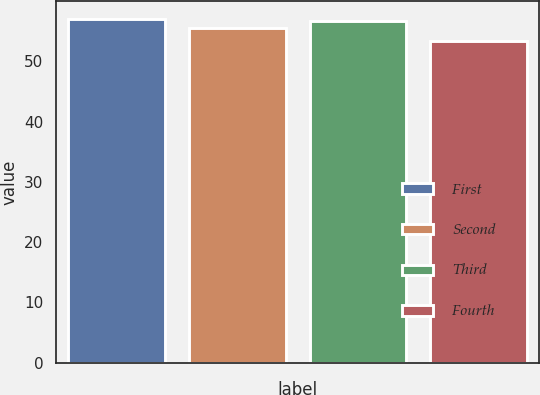<chart> <loc_0><loc_0><loc_500><loc_500><bar_chart><fcel>First<fcel>Second<fcel>Third<fcel>Fourth<nl><fcel>57.11<fcel>55.6<fcel>56.76<fcel>53.36<nl></chart> 